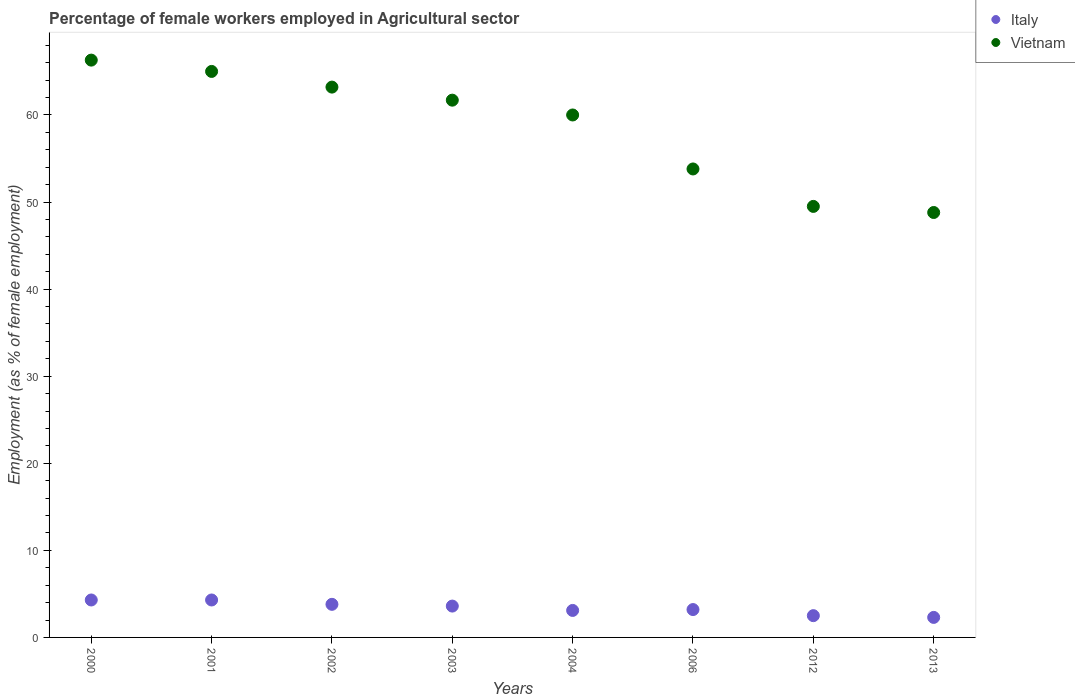How many different coloured dotlines are there?
Keep it short and to the point. 2. Is the number of dotlines equal to the number of legend labels?
Your response must be concise. Yes. What is the percentage of females employed in Agricultural sector in Vietnam in 2013?
Your answer should be compact. 48.8. Across all years, what is the maximum percentage of females employed in Agricultural sector in Italy?
Provide a succinct answer. 4.3. Across all years, what is the minimum percentage of females employed in Agricultural sector in Vietnam?
Keep it short and to the point. 48.8. What is the total percentage of females employed in Agricultural sector in Italy in the graph?
Give a very brief answer. 27.1. What is the difference between the percentage of females employed in Agricultural sector in Italy in 2000 and that in 2003?
Make the answer very short. 0.7. What is the difference between the percentage of females employed in Agricultural sector in Italy in 2002 and the percentage of females employed in Agricultural sector in Vietnam in 2013?
Offer a terse response. -45. What is the average percentage of females employed in Agricultural sector in Italy per year?
Provide a succinct answer. 3.39. In the year 2001, what is the difference between the percentage of females employed in Agricultural sector in Italy and percentage of females employed in Agricultural sector in Vietnam?
Make the answer very short. -60.7. In how many years, is the percentage of females employed in Agricultural sector in Vietnam greater than 30 %?
Your response must be concise. 8. What is the ratio of the percentage of females employed in Agricultural sector in Italy in 2000 to that in 2012?
Make the answer very short. 1.72. Is the percentage of females employed in Agricultural sector in Italy in 2001 less than that in 2003?
Your response must be concise. No. Is the difference between the percentage of females employed in Agricultural sector in Italy in 2000 and 2004 greater than the difference between the percentage of females employed in Agricultural sector in Vietnam in 2000 and 2004?
Provide a succinct answer. No. What is the difference between the highest and the second highest percentage of females employed in Agricultural sector in Italy?
Your response must be concise. 0. What is the difference between the highest and the lowest percentage of females employed in Agricultural sector in Italy?
Ensure brevity in your answer.  2. In how many years, is the percentage of females employed in Agricultural sector in Italy greater than the average percentage of females employed in Agricultural sector in Italy taken over all years?
Your answer should be compact. 4. Is the sum of the percentage of females employed in Agricultural sector in Italy in 2000 and 2001 greater than the maximum percentage of females employed in Agricultural sector in Vietnam across all years?
Provide a succinct answer. No. Is the percentage of females employed in Agricultural sector in Vietnam strictly less than the percentage of females employed in Agricultural sector in Italy over the years?
Give a very brief answer. No. How many dotlines are there?
Offer a very short reply. 2. How many years are there in the graph?
Your answer should be compact. 8. What is the difference between two consecutive major ticks on the Y-axis?
Ensure brevity in your answer.  10. Are the values on the major ticks of Y-axis written in scientific E-notation?
Your response must be concise. No. Does the graph contain any zero values?
Your answer should be very brief. No. Does the graph contain grids?
Your answer should be very brief. No. Where does the legend appear in the graph?
Give a very brief answer. Top right. How many legend labels are there?
Your answer should be very brief. 2. How are the legend labels stacked?
Keep it short and to the point. Vertical. What is the title of the graph?
Offer a very short reply. Percentage of female workers employed in Agricultural sector. What is the label or title of the Y-axis?
Your answer should be very brief. Employment (as % of female employment). What is the Employment (as % of female employment) of Italy in 2000?
Your response must be concise. 4.3. What is the Employment (as % of female employment) in Vietnam in 2000?
Offer a terse response. 66.3. What is the Employment (as % of female employment) of Italy in 2001?
Give a very brief answer. 4.3. What is the Employment (as % of female employment) of Italy in 2002?
Offer a very short reply. 3.8. What is the Employment (as % of female employment) in Vietnam in 2002?
Offer a terse response. 63.2. What is the Employment (as % of female employment) of Italy in 2003?
Make the answer very short. 3.6. What is the Employment (as % of female employment) of Vietnam in 2003?
Make the answer very short. 61.7. What is the Employment (as % of female employment) of Italy in 2004?
Your answer should be very brief. 3.1. What is the Employment (as % of female employment) in Vietnam in 2004?
Your answer should be compact. 60. What is the Employment (as % of female employment) of Italy in 2006?
Offer a terse response. 3.2. What is the Employment (as % of female employment) in Vietnam in 2006?
Ensure brevity in your answer.  53.8. What is the Employment (as % of female employment) of Italy in 2012?
Your answer should be very brief. 2.5. What is the Employment (as % of female employment) in Vietnam in 2012?
Provide a short and direct response. 49.5. What is the Employment (as % of female employment) of Italy in 2013?
Offer a very short reply. 2.3. What is the Employment (as % of female employment) in Vietnam in 2013?
Offer a very short reply. 48.8. Across all years, what is the maximum Employment (as % of female employment) of Italy?
Offer a very short reply. 4.3. Across all years, what is the maximum Employment (as % of female employment) in Vietnam?
Your response must be concise. 66.3. Across all years, what is the minimum Employment (as % of female employment) of Italy?
Ensure brevity in your answer.  2.3. Across all years, what is the minimum Employment (as % of female employment) of Vietnam?
Your answer should be compact. 48.8. What is the total Employment (as % of female employment) of Italy in the graph?
Your response must be concise. 27.1. What is the total Employment (as % of female employment) in Vietnam in the graph?
Give a very brief answer. 468.3. What is the difference between the Employment (as % of female employment) in Italy in 2000 and that in 2002?
Your response must be concise. 0.5. What is the difference between the Employment (as % of female employment) in Italy in 2000 and that in 2004?
Your answer should be very brief. 1.2. What is the difference between the Employment (as % of female employment) of Vietnam in 2000 and that in 2006?
Give a very brief answer. 12.5. What is the difference between the Employment (as % of female employment) of Italy in 2000 and that in 2013?
Provide a short and direct response. 2. What is the difference between the Employment (as % of female employment) of Vietnam in 2000 and that in 2013?
Offer a very short reply. 17.5. What is the difference between the Employment (as % of female employment) of Italy in 2001 and that in 2002?
Your answer should be compact. 0.5. What is the difference between the Employment (as % of female employment) of Vietnam in 2001 and that in 2002?
Your answer should be compact. 1.8. What is the difference between the Employment (as % of female employment) of Italy in 2001 and that in 2003?
Your answer should be compact. 0.7. What is the difference between the Employment (as % of female employment) in Vietnam in 2001 and that in 2003?
Ensure brevity in your answer.  3.3. What is the difference between the Employment (as % of female employment) in Vietnam in 2001 and that in 2004?
Make the answer very short. 5. What is the difference between the Employment (as % of female employment) in Italy in 2001 and that in 2012?
Your response must be concise. 1.8. What is the difference between the Employment (as % of female employment) of Vietnam in 2001 and that in 2012?
Keep it short and to the point. 15.5. What is the difference between the Employment (as % of female employment) in Vietnam in 2001 and that in 2013?
Keep it short and to the point. 16.2. What is the difference between the Employment (as % of female employment) of Vietnam in 2002 and that in 2004?
Provide a succinct answer. 3.2. What is the difference between the Employment (as % of female employment) in Vietnam in 2002 and that in 2006?
Your answer should be compact. 9.4. What is the difference between the Employment (as % of female employment) of Italy in 2002 and that in 2013?
Your answer should be very brief. 1.5. What is the difference between the Employment (as % of female employment) of Italy in 2003 and that in 2006?
Offer a terse response. 0.4. What is the difference between the Employment (as % of female employment) in Vietnam in 2003 and that in 2006?
Provide a succinct answer. 7.9. What is the difference between the Employment (as % of female employment) of Italy in 2003 and that in 2012?
Provide a short and direct response. 1.1. What is the difference between the Employment (as % of female employment) in Vietnam in 2004 and that in 2006?
Offer a terse response. 6.2. What is the difference between the Employment (as % of female employment) of Vietnam in 2004 and that in 2012?
Your answer should be compact. 10.5. What is the difference between the Employment (as % of female employment) in Italy in 2006 and that in 2012?
Your answer should be compact. 0.7. What is the difference between the Employment (as % of female employment) of Vietnam in 2006 and that in 2012?
Give a very brief answer. 4.3. What is the difference between the Employment (as % of female employment) of Italy in 2012 and that in 2013?
Provide a succinct answer. 0.2. What is the difference between the Employment (as % of female employment) in Italy in 2000 and the Employment (as % of female employment) in Vietnam in 2001?
Provide a succinct answer. -60.7. What is the difference between the Employment (as % of female employment) of Italy in 2000 and the Employment (as % of female employment) of Vietnam in 2002?
Provide a succinct answer. -58.9. What is the difference between the Employment (as % of female employment) in Italy in 2000 and the Employment (as % of female employment) in Vietnam in 2003?
Ensure brevity in your answer.  -57.4. What is the difference between the Employment (as % of female employment) in Italy in 2000 and the Employment (as % of female employment) in Vietnam in 2004?
Offer a terse response. -55.7. What is the difference between the Employment (as % of female employment) in Italy in 2000 and the Employment (as % of female employment) in Vietnam in 2006?
Your answer should be very brief. -49.5. What is the difference between the Employment (as % of female employment) in Italy in 2000 and the Employment (as % of female employment) in Vietnam in 2012?
Ensure brevity in your answer.  -45.2. What is the difference between the Employment (as % of female employment) in Italy in 2000 and the Employment (as % of female employment) in Vietnam in 2013?
Give a very brief answer. -44.5. What is the difference between the Employment (as % of female employment) in Italy in 2001 and the Employment (as % of female employment) in Vietnam in 2002?
Keep it short and to the point. -58.9. What is the difference between the Employment (as % of female employment) in Italy in 2001 and the Employment (as % of female employment) in Vietnam in 2003?
Make the answer very short. -57.4. What is the difference between the Employment (as % of female employment) in Italy in 2001 and the Employment (as % of female employment) in Vietnam in 2004?
Give a very brief answer. -55.7. What is the difference between the Employment (as % of female employment) of Italy in 2001 and the Employment (as % of female employment) of Vietnam in 2006?
Provide a succinct answer. -49.5. What is the difference between the Employment (as % of female employment) in Italy in 2001 and the Employment (as % of female employment) in Vietnam in 2012?
Keep it short and to the point. -45.2. What is the difference between the Employment (as % of female employment) of Italy in 2001 and the Employment (as % of female employment) of Vietnam in 2013?
Provide a succinct answer. -44.5. What is the difference between the Employment (as % of female employment) of Italy in 2002 and the Employment (as % of female employment) of Vietnam in 2003?
Make the answer very short. -57.9. What is the difference between the Employment (as % of female employment) of Italy in 2002 and the Employment (as % of female employment) of Vietnam in 2004?
Ensure brevity in your answer.  -56.2. What is the difference between the Employment (as % of female employment) of Italy in 2002 and the Employment (as % of female employment) of Vietnam in 2012?
Make the answer very short. -45.7. What is the difference between the Employment (as % of female employment) in Italy in 2002 and the Employment (as % of female employment) in Vietnam in 2013?
Provide a succinct answer. -45. What is the difference between the Employment (as % of female employment) of Italy in 2003 and the Employment (as % of female employment) of Vietnam in 2004?
Ensure brevity in your answer.  -56.4. What is the difference between the Employment (as % of female employment) of Italy in 2003 and the Employment (as % of female employment) of Vietnam in 2006?
Offer a terse response. -50.2. What is the difference between the Employment (as % of female employment) in Italy in 2003 and the Employment (as % of female employment) in Vietnam in 2012?
Your answer should be very brief. -45.9. What is the difference between the Employment (as % of female employment) in Italy in 2003 and the Employment (as % of female employment) in Vietnam in 2013?
Keep it short and to the point. -45.2. What is the difference between the Employment (as % of female employment) in Italy in 2004 and the Employment (as % of female employment) in Vietnam in 2006?
Provide a short and direct response. -50.7. What is the difference between the Employment (as % of female employment) in Italy in 2004 and the Employment (as % of female employment) in Vietnam in 2012?
Offer a terse response. -46.4. What is the difference between the Employment (as % of female employment) in Italy in 2004 and the Employment (as % of female employment) in Vietnam in 2013?
Your answer should be compact. -45.7. What is the difference between the Employment (as % of female employment) in Italy in 2006 and the Employment (as % of female employment) in Vietnam in 2012?
Give a very brief answer. -46.3. What is the difference between the Employment (as % of female employment) in Italy in 2006 and the Employment (as % of female employment) in Vietnam in 2013?
Ensure brevity in your answer.  -45.6. What is the difference between the Employment (as % of female employment) of Italy in 2012 and the Employment (as % of female employment) of Vietnam in 2013?
Make the answer very short. -46.3. What is the average Employment (as % of female employment) of Italy per year?
Provide a succinct answer. 3.39. What is the average Employment (as % of female employment) of Vietnam per year?
Provide a succinct answer. 58.54. In the year 2000, what is the difference between the Employment (as % of female employment) of Italy and Employment (as % of female employment) of Vietnam?
Offer a very short reply. -62. In the year 2001, what is the difference between the Employment (as % of female employment) in Italy and Employment (as % of female employment) in Vietnam?
Your answer should be compact. -60.7. In the year 2002, what is the difference between the Employment (as % of female employment) of Italy and Employment (as % of female employment) of Vietnam?
Make the answer very short. -59.4. In the year 2003, what is the difference between the Employment (as % of female employment) in Italy and Employment (as % of female employment) in Vietnam?
Offer a terse response. -58.1. In the year 2004, what is the difference between the Employment (as % of female employment) of Italy and Employment (as % of female employment) of Vietnam?
Make the answer very short. -56.9. In the year 2006, what is the difference between the Employment (as % of female employment) of Italy and Employment (as % of female employment) of Vietnam?
Your answer should be compact. -50.6. In the year 2012, what is the difference between the Employment (as % of female employment) in Italy and Employment (as % of female employment) in Vietnam?
Offer a terse response. -47. In the year 2013, what is the difference between the Employment (as % of female employment) of Italy and Employment (as % of female employment) of Vietnam?
Your response must be concise. -46.5. What is the ratio of the Employment (as % of female employment) of Vietnam in 2000 to that in 2001?
Your answer should be compact. 1.02. What is the ratio of the Employment (as % of female employment) of Italy in 2000 to that in 2002?
Ensure brevity in your answer.  1.13. What is the ratio of the Employment (as % of female employment) in Vietnam in 2000 to that in 2002?
Offer a terse response. 1.05. What is the ratio of the Employment (as % of female employment) of Italy in 2000 to that in 2003?
Give a very brief answer. 1.19. What is the ratio of the Employment (as % of female employment) in Vietnam in 2000 to that in 2003?
Offer a very short reply. 1.07. What is the ratio of the Employment (as % of female employment) in Italy in 2000 to that in 2004?
Provide a short and direct response. 1.39. What is the ratio of the Employment (as % of female employment) of Vietnam in 2000 to that in 2004?
Your answer should be compact. 1.1. What is the ratio of the Employment (as % of female employment) of Italy in 2000 to that in 2006?
Offer a terse response. 1.34. What is the ratio of the Employment (as % of female employment) of Vietnam in 2000 to that in 2006?
Your answer should be very brief. 1.23. What is the ratio of the Employment (as % of female employment) in Italy in 2000 to that in 2012?
Make the answer very short. 1.72. What is the ratio of the Employment (as % of female employment) of Vietnam in 2000 to that in 2012?
Ensure brevity in your answer.  1.34. What is the ratio of the Employment (as % of female employment) in Italy in 2000 to that in 2013?
Your response must be concise. 1.87. What is the ratio of the Employment (as % of female employment) in Vietnam in 2000 to that in 2013?
Provide a succinct answer. 1.36. What is the ratio of the Employment (as % of female employment) in Italy in 2001 to that in 2002?
Offer a very short reply. 1.13. What is the ratio of the Employment (as % of female employment) in Vietnam in 2001 to that in 2002?
Give a very brief answer. 1.03. What is the ratio of the Employment (as % of female employment) of Italy in 2001 to that in 2003?
Provide a succinct answer. 1.19. What is the ratio of the Employment (as % of female employment) of Vietnam in 2001 to that in 2003?
Offer a terse response. 1.05. What is the ratio of the Employment (as % of female employment) of Italy in 2001 to that in 2004?
Your response must be concise. 1.39. What is the ratio of the Employment (as % of female employment) of Vietnam in 2001 to that in 2004?
Offer a very short reply. 1.08. What is the ratio of the Employment (as % of female employment) in Italy in 2001 to that in 2006?
Offer a terse response. 1.34. What is the ratio of the Employment (as % of female employment) in Vietnam in 2001 to that in 2006?
Your response must be concise. 1.21. What is the ratio of the Employment (as % of female employment) in Italy in 2001 to that in 2012?
Ensure brevity in your answer.  1.72. What is the ratio of the Employment (as % of female employment) of Vietnam in 2001 to that in 2012?
Ensure brevity in your answer.  1.31. What is the ratio of the Employment (as % of female employment) of Italy in 2001 to that in 2013?
Offer a terse response. 1.87. What is the ratio of the Employment (as % of female employment) in Vietnam in 2001 to that in 2013?
Ensure brevity in your answer.  1.33. What is the ratio of the Employment (as % of female employment) in Italy in 2002 to that in 2003?
Provide a succinct answer. 1.06. What is the ratio of the Employment (as % of female employment) in Vietnam in 2002 to that in 2003?
Offer a very short reply. 1.02. What is the ratio of the Employment (as % of female employment) in Italy in 2002 to that in 2004?
Your response must be concise. 1.23. What is the ratio of the Employment (as % of female employment) of Vietnam in 2002 to that in 2004?
Make the answer very short. 1.05. What is the ratio of the Employment (as % of female employment) of Italy in 2002 to that in 2006?
Your answer should be very brief. 1.19. What is the ratio of the Employment (as % of female employment) of Vietnam in 2002 to that in 2006?
Your response must be concise. 1.17. What is the ratio of the Employment (as % of female employment) in Italy in 2002 to that in 2012?
Offer a terse response. 1.52. What is the ratio of the Employment (as % of female employment) of Vietnam in 2002 to that in 2012?
Make the answer very short. 1.28. What is the ratio of the Employment (as % of female employment) of Italy in 2002 to that in 2013?
Your answer should be compact. 1.65. What is the ratio of the Employment (as % of female employment) in Vietnam in 2002 to that in 2013?
Your response must be concise. 1.3. What is the ratio of the Employment (as % of female employment) of Italy in 2003 to that in 2004?
Your answer should be very brief. 1.16. What is the ratio of the Employment (as % of female employment) in Vietnam in 2003 to that in 2004?
Provide a succinct answer. 1.03. What is the ratio of the Employment (as % of female employment) of Vietnam in 2003 to that in 2006?
Offer a very short reply. 1.15. What is the ratio of the Employment (as % of female employment) in Italy in 2003 to that in 2012?
Provide a short and direct response. 1.44. What is the ratio of the Employment (as % of female employment) in Vietnam in 2003 to that in 2012?
Make the answer very short. 1.25. What is the ratio of the Employment (as % of female employment) of Italy in 2003 to that in 2013?
Make the answer very short. 1.57. What is the ratio of the Employment (as % of female employment) in Vietnam in 2003 to that in 2013?
Offer a terse response. 1.26. What is the ratio of the Employment (as % of female employment) in Italy in 2004 to that in 2006?
Provide a succinct answer. 0.97. What is the ratio of the Employment (as % of female employment) of Vietnam in 2004 to that in 2006?
Your answer should be very brief. 1.12. What is the ratio of the Employment (as % of female employment) of Italy in 2004 to that in 2012?
Offer a very short reply. 1.24. What is the ratio of the Employment (as % of female employment) of Vietnam in 2004 to that in 2012?
Offer a very short reply. 1.21. What is the ratio of the Employment (as % of female employment) of Italy in 2004 to that in 2013?
Offer a very short reply. 1.35. What is the ratio of the Employment (as % of female employment) of Vietnam in 2004 to that in 2013?
Provide a succinct answer. 1.23. What is the ratio of the Employment (as % of female employment) in Italy in 2006 to that in 2012?
Offer a terse response. 1.28. What is the ratio of the Employment (as % of female employment) of Vietnam in 2006 to that in 2012?
Your answer should be very brief. 1.09. What is the ratio of the Employment (as % of female employment) of Italy in 2006 to that in 2013?
Your response must be concise. 1.39. What is the ratio of the Employment (as % of female employment) in Vietnam in 2006 to that in 2013?
Provide a short and direct response. 1.1. What is the ratio of the Employment (as % of female employment) of Italy in 2012 to that in 2013?
Make the answer very short. 1.09. What is the ratio of the Employment (as % of female employment) of Vietnam in 2012 to that in 2013?
Give a very brief answer. 1.01. What is the difference between the highest and the second highest Employment (as % of female employment) of Italy?
Your answer should be very brief. 0. What is the difference between the highest and the second highest Employment (as % of female employment) of Vietnam?
Give a very brief answer. 1.3. What is the difference between the highest and the lowest Employment (as % of female employment) of Italy?
Your response must be concise. 2. What is the difference between the highest and the lowest Employment (as % of female employment) of Vietnam?
Give a very brief answer. 17.5. 